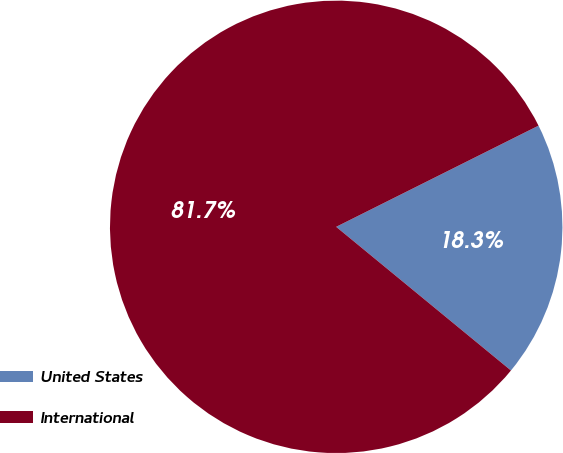<chart> <loc_0><loc_0><loc_500><loc_500><pie_chart><fcel>United States<fcel>International<nl><fcel>18.33%<fcel>81.67%<nl></chart> 